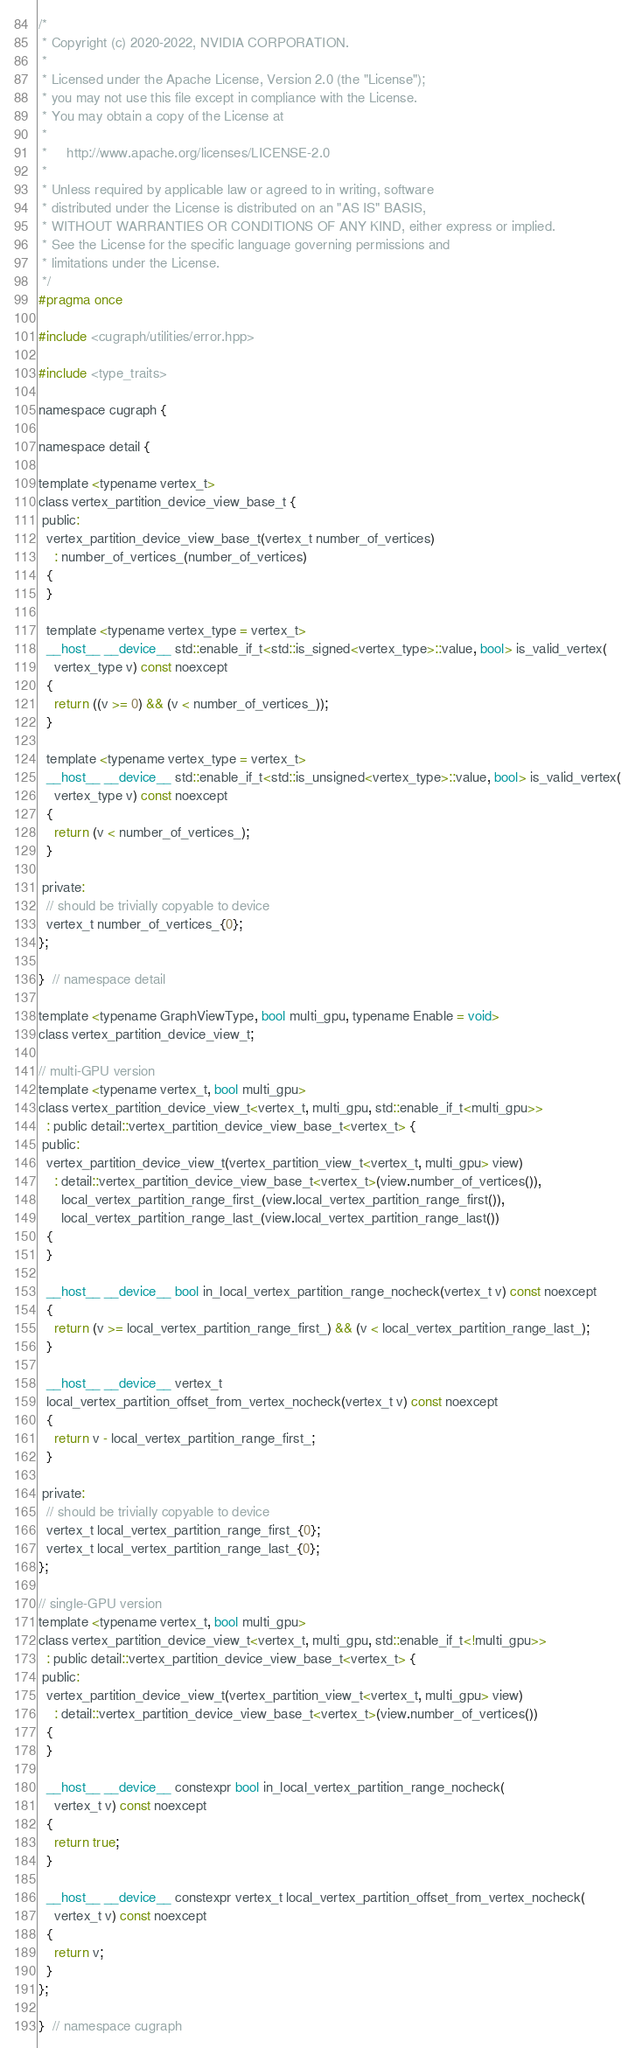<code> <loc_0><loc_0><loc_500><loc_500><_Cuda_>/*
 * Copyright (c) 2020-2022, NVIDIA CORPORATION.
 *
 * Licensed under the Apache License, Version 2.0 (the "License");
 * you may not use this file except in compliance with the License.
 * You may obtain a copy of the License at
 *
 *     http://www.apache.org/licenses/LICENSE-2.0
 *
 * Unless required by applicable law or agreed to in writing, software
 * distributed under the License is distributed on an "AS IS" BASIS,
 * WITHOUT WARRANTIES OR CONDITIONS OF ANY KIND, either express or implied.
 * See the License for the specific language governing permissions and
 * limitations under the License.
 */
#pragma once

#include <cugraph/utilities/error.hpp>

#include <type_traits>

namespace cugraph {

namespace detail {

template <typename vertex_t>
class vertex_partition_device_view_base_t {
 public:
  vertex_partition_device_view_base_t(vertex_t number_of_vertices)
    : number_of_vertices_(number_of_vertices)
  {
  }

  template <typename vertex_type = vertex_t>
  __host__ __device__ std::enable_if_t<std::is_signed<vertex_type>::value, bool> is_valid_vertex(
    vertex_type v) const noexcept
  {
    return ((v >= 0) && (v < number_of_vertices_));
  }

  template <typename vertex_type = vertex_t>
  __host__ __device__ std::enable_if_t<std::is_unsigned<vertex_type>::value, bool> is_valid_vertex(
    vertex_type v) const noexcept
  {
    return (v < number_of_vertices_);
  }

 private:
  // should be trivially copyable to device
  vertex_t number_of_vertices_{0};
};

}  // namespace detail

template <typename GraphViewType, bool multi_gpu, typename Enable = void>
class vertex_partition_device_view_t;

// multi-GPU version
template <typename vertex_t, bool multi_gpu>
class vertex_partition_device_view_t<vertex_t, multi_gpu, std::enable_if_t<multi_gpu>>
  : public detail::vertex_partition_device_view_base_t<vertex_t> {
 public:
  vertex_partition_device_view_t(vertex_partition_view_t<vertex_t, multi_gpu> view)
    : detail::vertex_partition_device_view_base_t<vertex_t>(view.number_of_vertices()),
      local_vertex_partition_range_first_(view.local_vertex_partition_range_first()),
      local_vertex_partition_range_last_(view.local_vertex_partition_range_last())
  {
  }

  __host__ __device__ bool in_local_vertex_partition_range_nocheck(vertex_t v) const noexcept
  {
    return (v >= local_vertex_partition_range_first_) && (v < local_vertex_partition_range_last_);
  }

  __host__ __device__ vertex_t
  local_vertex_partition_offset_from_vertex_nocheck(vertex_t v) const noexcept
  {
    return v - local_vertex_partition_range_first_;
  }

 private:
  // should be trivially copyable to device
  vertex_t local_vertex_partition_range_first_{0};
  vertex_t local_vertex_partition_range_last_{0};
};

// single-GPU version
template <typename vertex_t, bool multi_gpu>
class vertex_partition_device_view_t<vertex_t, multi_gpu, std::enable_if_t<!multi_gpu>>
  : public detail::vertex_partition_device_view_base_t<vertex_t> {
 public:
  vertex_partition_device_view_t(vertex_partition_view_t<vertex_t, multi_gpu> view)
    : detail::vertex_partition_device_view_base_t<vertex_t>(view.number_of_vertices())
  {
  }

  __host__ __device__ constexpr bool in_local_vertex_partition_range_nocheck(
    vertex_t v) const noexcept
  {
    return true;
  }

  __host__ __device__ constexpr vertex_t local_vertex_partition_offset_from_vertex_nocheck(
    vertex_t v) const noexcept
  {
    return v;
  }
};

}  // namespace cugraph
</code> 